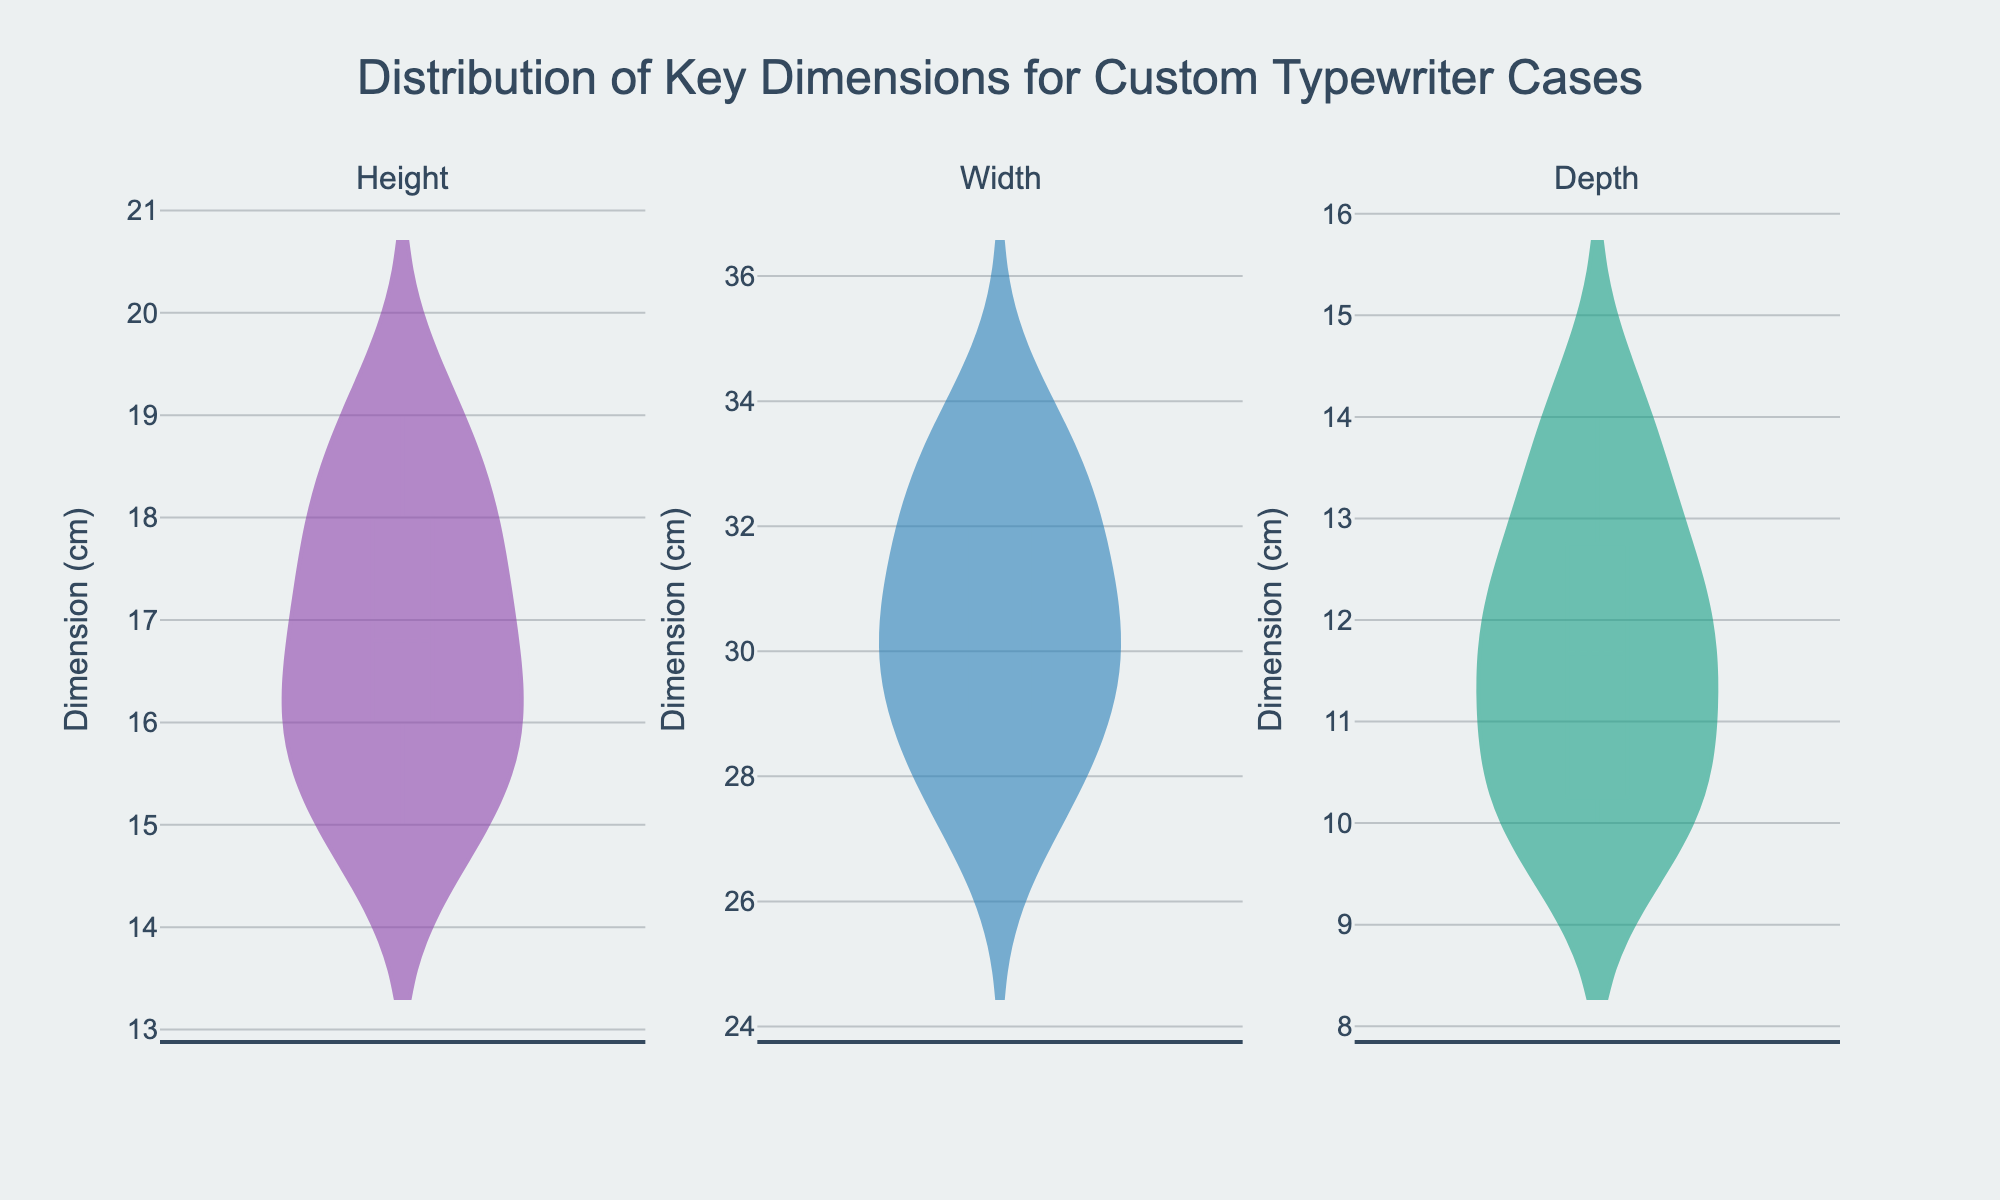What is the title of the figure? The title is typically located at the top center of the figure. It is the first textual element that catches the eye.
Answer: Distribution of Key Dimensions for Custom Typewriter Cases What does the y-axis represent? The y-axis label is provided in the figure, and it represents the measurement dimension in centimeters.
Answer: Dimension (cm) Which dimension has the widest distribution? By observing the width of the violin plots, we can see that the Width dimension has the broadest range.
Answer: Width Which dimension has the highest mean? Each violin plot has a mean line, and the median is marked within the box plot. Observing these, we see that the Width dimension's mean line is higher than those for Height and Depth.
Answer: Width Are any dimensions skewed, and which ones? Skewed distributions lean towards one side, which is apparent from the shape of the violin plots. The Depth distribution shows a slight skew to the right, indicating that most values are on the lower side, while the Height and Width distributions appear more symmetrical.
Answer: Depth What is the median value for the Depth dimension? The median is indicated by the line inside the box of the violin plot. For the Depth dimension, the median line aligns approximately at 12 cm.
Answer: 12 cm Between Height and Depth, which has a broader range of values? By comparing the range covered by the violin plots for Height and Depth, we can see that Height has values ranging from 15 to 19, while Depth ranges from 10 to 14. Thus, Height has a broader range.
Answer: Height Which dimension has the smallest interquartile range? The interquartile range (IQR) is the range between the first and third quartiles, represented by the width of the box in the violin plot. Based on the plots, the Depth dimension has the smallest IQR.
Answer: Depth What is the most frequent value for the Height dimension? The height of the violin plot's widest section represents the most frequent value. For the Height dimension, the most frequent value is around 17 cm.
Answer: 17 cm 